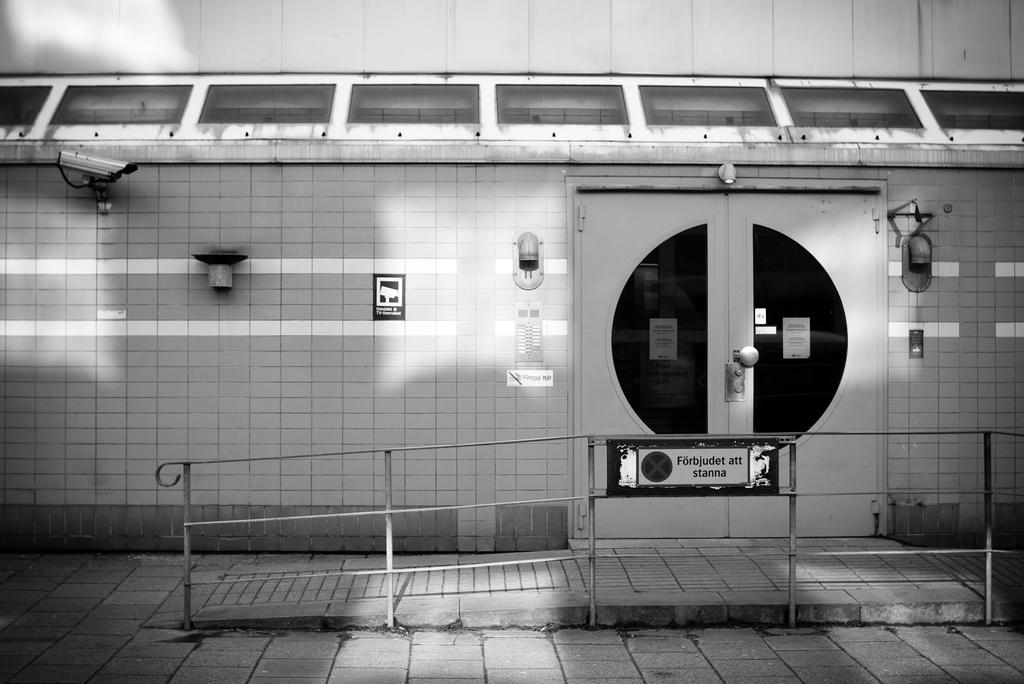What is the color scheme of the image? The image is black and white. What type of structure can be seen in the image? There is steel railing in the image. What other objects are present in the image? There is a board, doors, a CCTV camera, and lights fixed to the wall in the image. What type of badge is the police officer wearing in the image? There are no police officers or badges present in the image. How does the sleet affect the visibility of the CCTV camera in the image? There is no mention of sleet in the image, and the visibility of the CCTV camera is not affected by any weather conditions. 